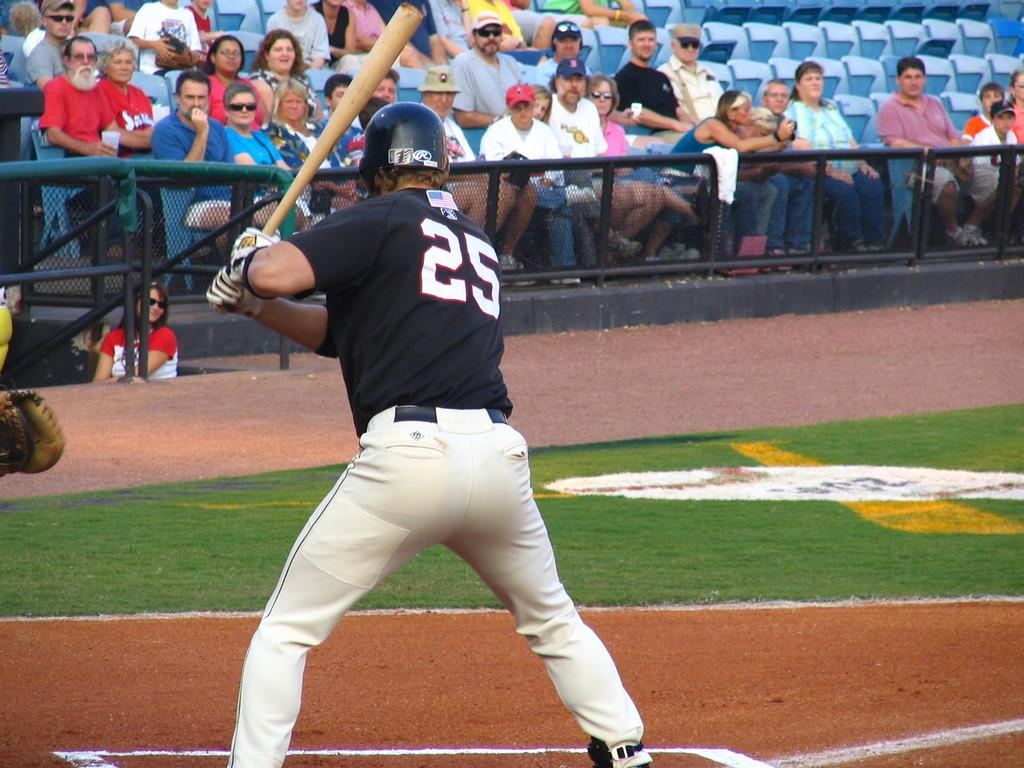Provide a one-sentence caption for the provided image. A baseball player wearing number 25 is batting. 